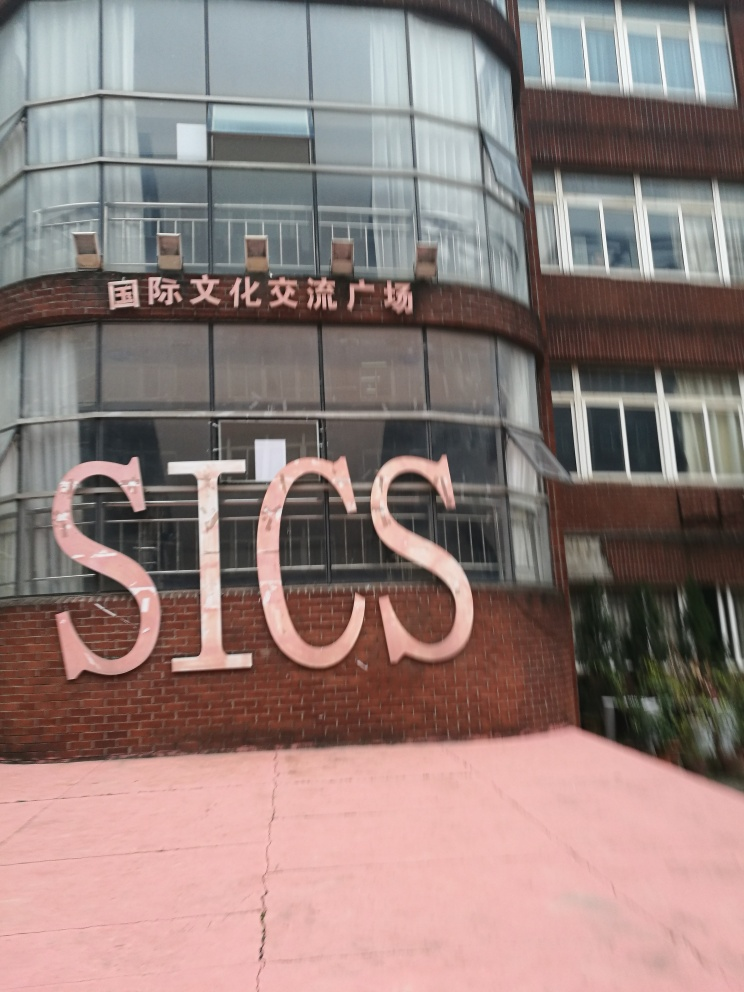What time of day does it appear to be in this photograph? The photograph lacks strong shadows or lighting cues that usually indicate the time of day. Without clear shadows or a view of the sky, it's difficult to accurately assess the time when this picture was taken. 